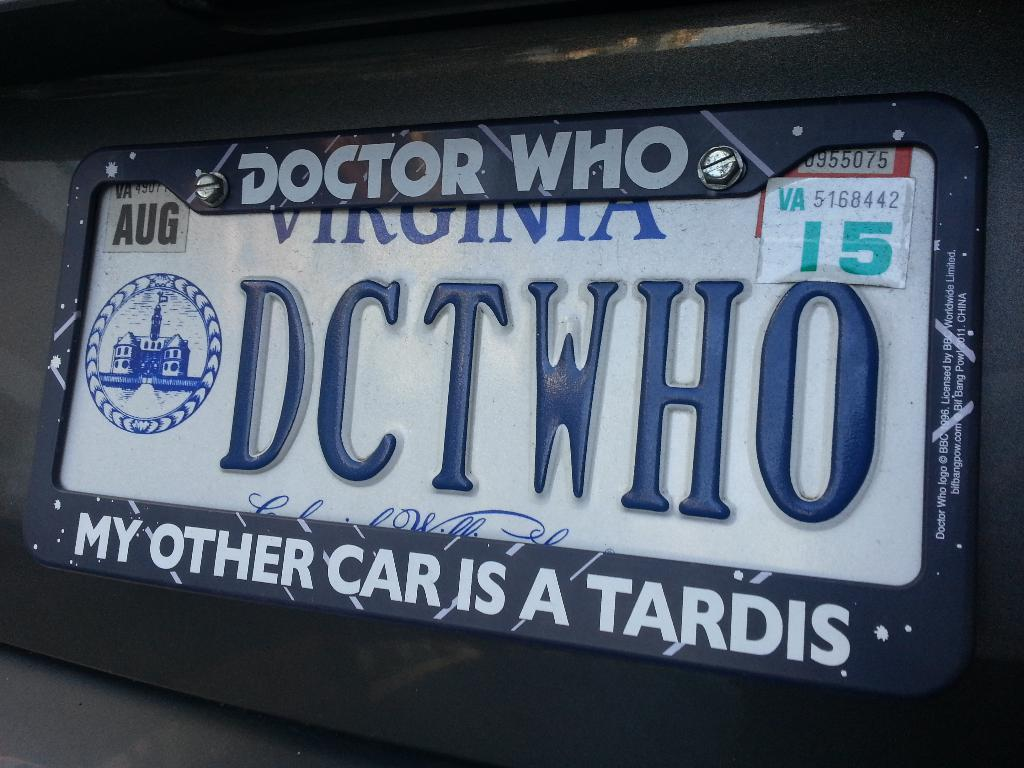<image>
Relay a brief, clear account of the picture shown. A Virginia license plate has DCTWHO in blue letters. 